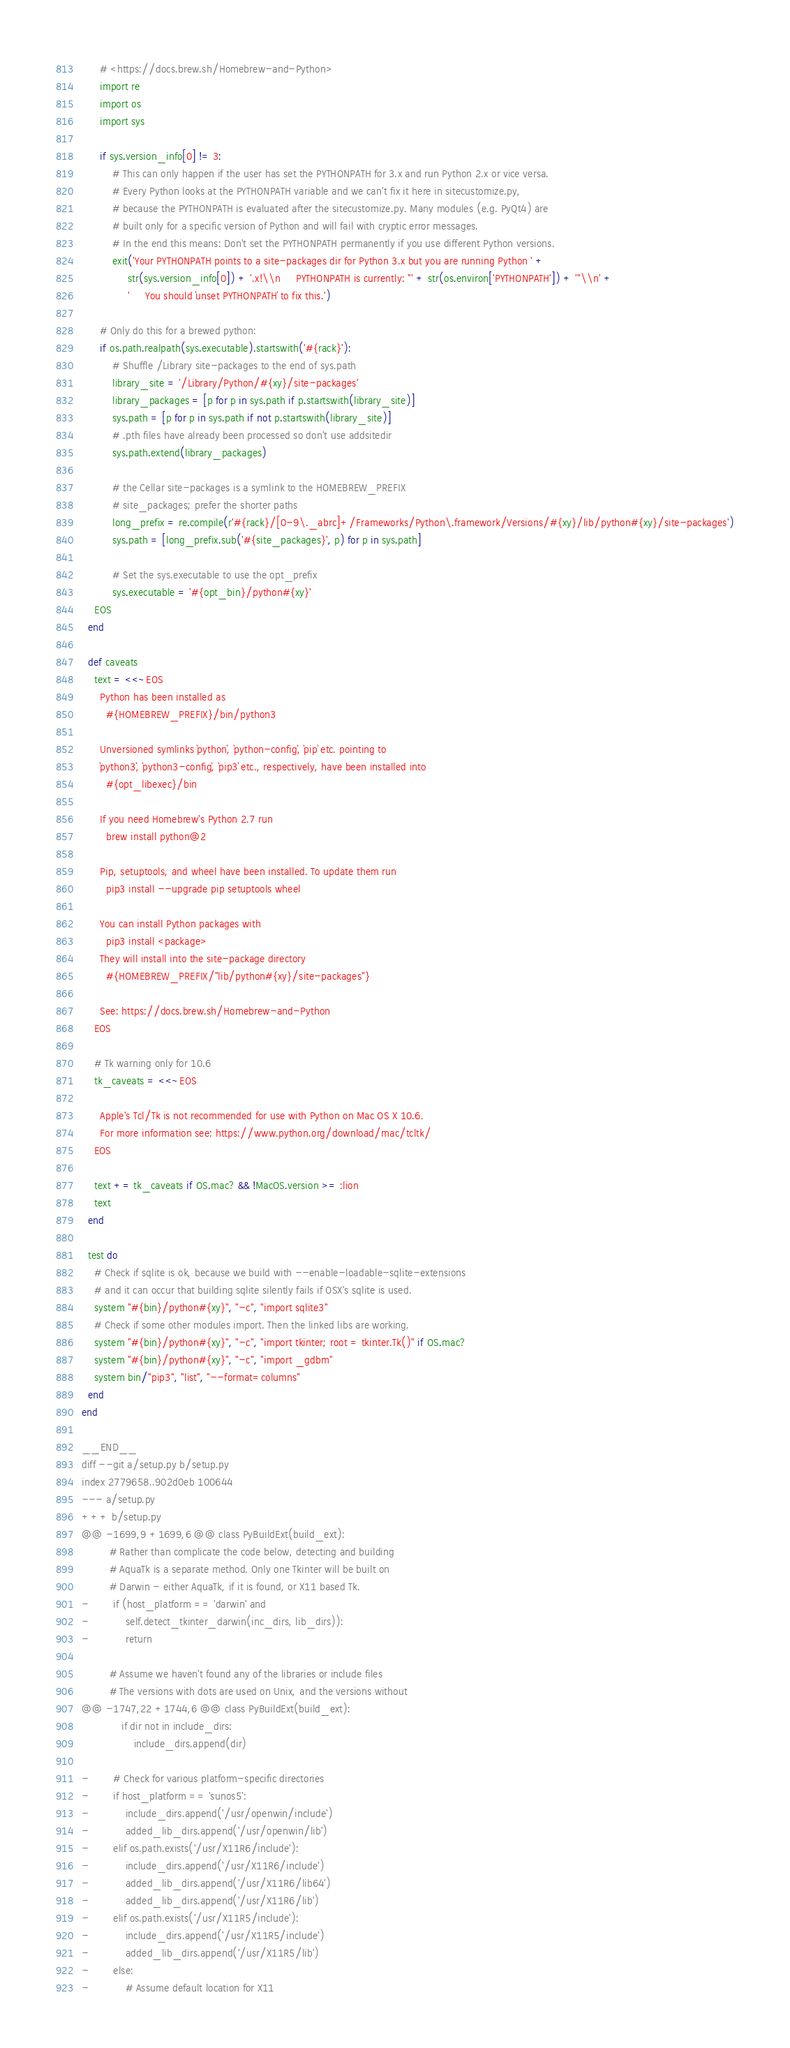<code> <loc_0><loc_0><loc_500><loc_500><_Ruby_>      # <https://docs.brew.sh/Homebrew-and-Python>
      import re
      import os
      import sys

      if sys.version_info[0] != 3:
          # This can only happen if the user has set the PYTHONPATH for 3.x and run Python 2.x or vice versa.
          # Every Python looks at the PYTHONPATH variable and we can't fix it here in sitecustomize.py,
          # because the PYTHONPATH is evaluated after the sitecustomize.py. Many modules (e.g. PyQt4) are
          # built only for a specific version of Python and will fail with cryptic error messages.
          # In the end this means: Don't set the PYTHONPATH permanently if you use different Python versions.
          exit('Your PYTHONPATH points to a site-packages dir for Python 3.x but you are running Python ' +
               str(sys.version_info[0]) + '.x!\\n     PYTHONPATH is currently: "' + str(os.environ['PYTHONPATH']) + '"\\n' +
               '     You should `unset PYTHONPATH` to fix this.')

      # Only do this for a brewed python:
      if os.path.realpath(sys.executable).startswith('#{rack}'):
          # Shuffle /Library site-packages to the end of sys.path
          library_site = '/Library/Python/#{xy}/site-packages'
          library_packages = [p for p in sys.path if p.startswith(library_site)]
          sys.path = [p for p in sys.path if not p.startswith(library_site)]
          # .pth files have already been processed so don't use addsitedir
          sys.path.extend(library_packages)

          # the Cellar site-packages is a symlink to the HOMEBREW_PREFIX
          # site_packages; prefer the shorter paths
          long_prefix = re.compile(r'#{rack}/[0-9\._abrc]+/Frameworks/Python\.framework/Versions/#{xy}/lib/python#{xy}/site-packages')
          sys.path = [long_prefix.sub('#{site_packages}', p) for p in sys.path]

          # Set the sys.executable to use the opt_prefix
          sys.executable = '#{opt_bin}/python#{xy}'
    EOS
  end

  def caveats
    text = <<~EOS
      Python has been installed as
        #{HOMEBREW_PREFIX}/bin/python3

      Unversioned symlinks `python`, `python-config`, `pip` etc. pointing to
      `python3`, `python3-config`, `pip3` etc., respectively, have been installed into
        #{opt_libexec}/bin

      If you need Homebrew's Python 2.7 run
        brew install python@2

      Pip, setuptools, and wheel have been installed. To update them run
        pip3 install --upgrade pip setuptools wheel

      You can install Python packages with
        pip3 install <package>
      They will install into the site-package directory
        #{HOMEBREW_PREFIX/"lib/python#{xy}/site-packages"}

      See: https://docs.brew.sh/Homebrew-and-Python
    EOS

    # Tk warning only for 10.6
    tk_caveats = <<~EOS

      Apple's Tcl/Tk is not recommended for use with Python on Mac OS X 10.6.
      For more information see: https://www.python.org/download/mac/tcltk/
    EOS

    text += tk_caveats if OS.mac? && !MacOS.version >= :lion
    text
  end

  test do
    # Check if sqlite is ok, because we build with --enable-loadable-sqlite-extensions
    # and it can occur that building sqlite silently fails if OSX's sqlite is used.
    system "#{bin}/python#{xy}", "-c", "import sqlite3"
    # Check if some other modules import. Then the linked libs are working.
    system "#{bin}/python#{xy}", "-c", "import tkinter; root = tkinter.Tk()" if OS.mac?
    system "#{bin}/python#{xy}", "-c", "import _gdbm"
    system bin/"pip3", "list", "--format=columns"
  end
end

__END__
diff --git a/setup.py b/setup.py
index 2779658..902d0eb 100644
--- a/setup.py
+++ b/setup.py
@@ -1699,9 +1699,6 @@ class PyBuildExt(build_ext):
         # Rather than complicate the code below, detecting and building
         # AquaTk is a separate method. Only one Tkinter will be built on
         # Darwin - either AquaTk, if it is found, or X11 based Tk.
-        if (host_platform == 'darwin' and
-            self.detect_tkinter_darwin(inc_dirs, lib_dirs)):
-            return

         # Assume we haven't found any of the libraries or include files
         # The versions with dots are used on Unix, and the versions without
@@ -1747,22 +1744,6 @@ class PyBuildExt(build_ext):
             if dir not in include_dirs:
                 include_dirs.append(dir)

-        # Check for various platform-specific directories
-        if host_platform == 'sunos5':
-            include_dirs.append('/usr/openwin/include')
-            added_lib_dirs.append('/usr/openwin/lib')
-        elif os.path.exists('/usr/X11R6/include'):
-            include_dirs.append('/usr/X11R6/include')
-            added_lib_dirs.append('/usr/X11R6/lib64')
-            added_lib_dirs.append('/usr/X11R6/lib')
-        elif os.path.exists('/usr/X11R5/include'):
-            include_dirs.append('/usr/X11R5/include')
-            added_lib_dirs.append('/usr/X11R5/lib')
-        else:
-            # Assume default location for X11</code> 